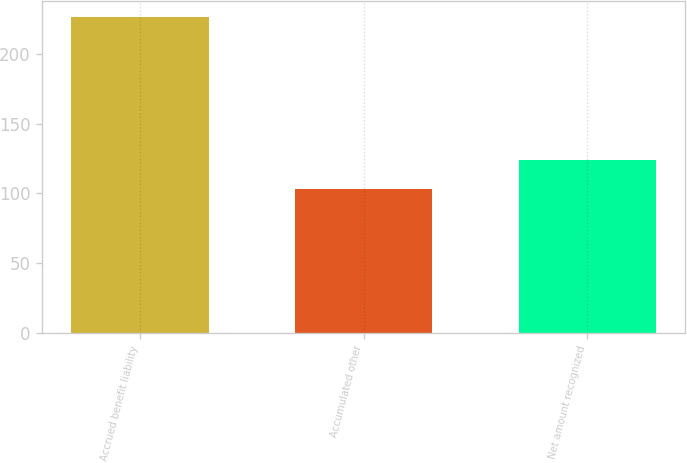Convert chart to OTSL. <chart><loc_0><loc_0><loc_500><loc_500><bar_chart><fcel>Accrued benefit liability<fcel>Accumulated other<fcel>Net amount recognized<nl><fcel>227<fcel>103<fcel>124<nl></chart> 